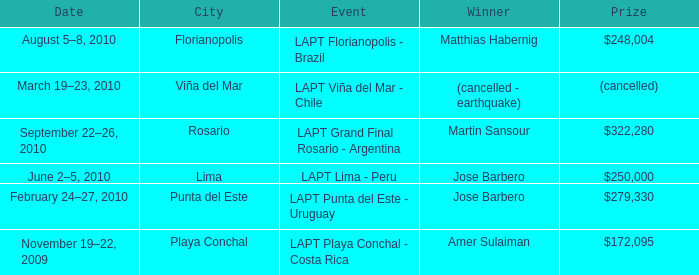What event is in florianopolis? LAPT Florianopolis - Brazil. 